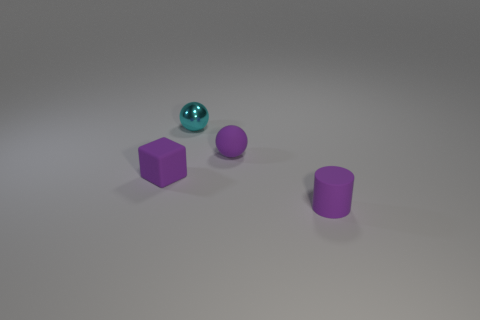Add 4 tiny purple metallic cylinders. How many objects exist? 8 Subtract all cubes. How many objects are left? 3 Add 1 tiny purple balls. How many tiny purple balls are left? 2 Add 1 small cubes. How many small cubes exist? 2 Subtract 0 brown cubes. How many objects are left? 4 Subtract all big yellow things. Subtract all tiny rubber cylinders. How many objects are left? 3 